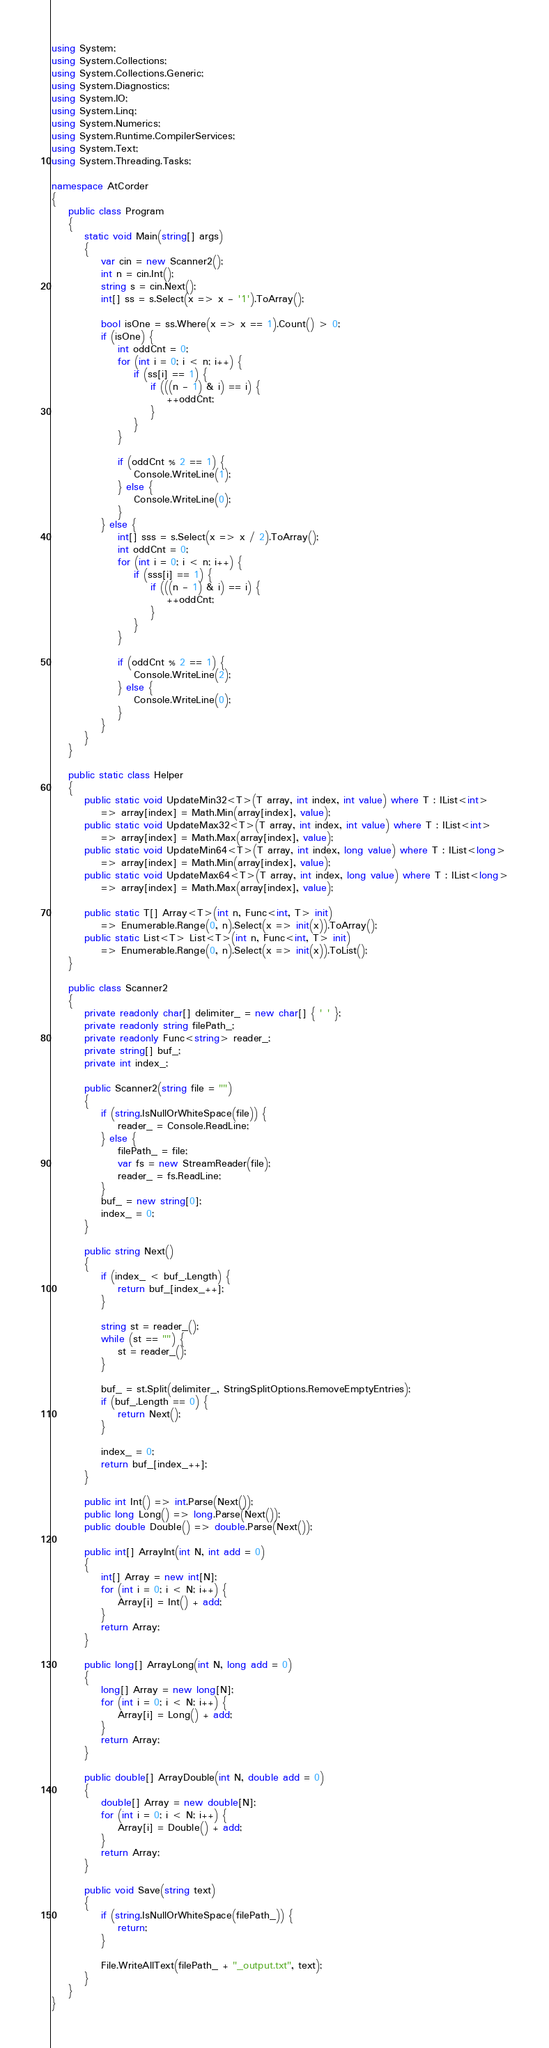Convert code to text. <code><loc_0><loc_0><loc_500><loc_500><_C#_>using System;
using System.Collections;
using System.Collections.Generic;
using System.Diagnostics;
using System.IO;
using System.Linq;
using System.Numerics;
using System.Runtime.CompilerServices;
using System.Text;
using System.Threading.Tasks;

namespace AtCorder
{
	public class Program
	{
		static void Main(string[] args)
		{
			var cin = new Scanner2();
			int n = cin.Int();
			string s = cin.Next();
			int[] ss = s.Select(x => x - '1').ToArray();

			bool isOne = ss.Where(x => x == 1).Count() > 0;
			if (isOne) {
				int oddCnt = 0;
				for (int i = 0; i < n; i++) {
					if (ss[i] == 1) {
						if (((n - 1) & i) == i) {
							++oddCnt;
						}
					}
				}

				if (oddCnt % 2 == 1) {
					Console.WriteLine(1);
				} else {
					Console.WriteLine(0);
				}
			} else {
				int[] sss = s.Select(x => x / 2).ToArray();
				int oddCnt = 0;
				for (int i = 0; i < n; i++) {
					if (sss[i] == 1) {
						if (((n - 1) & i) == i) {
							++oddCnt;
						}
					}
				}

				if (oddCnt % 2 == 1) {
					Console.WriteLine(2);
				} else {
					Console.WriteLine(0);
				}
			}
		}
	}

	public static class Helper
	{
		public static void UpdateMin32<T>(T array, int index, int value) where T : IList<int>
			=> array[index] = Math.Min(array[index], value);
		public static void UpdateMax32<T>(T array, int index, int value) where T : IList<int>
			=> array[index] = Math.Max(array[index], value);
		public static void UpdateMin64<T>(T array, int index, long value) where T : IList<long>
			=> array[index] = Math.Min(array[index], value);
		public static void UpdateMax64<T>(T array, int index, long value) where T : IList<long>
			=> array[index] = Math.Max(array[index], value);

		public static T[] Array<T>(int n, Func<int, T> init)
			=> Enumerable.Range(0, n).Select(x => init(x)).ToArray();
		public static List<T> List<T>(int n, Func<int, T> init)
			=> Enumerable.Range(0, n).Select(x => init(x)).ToList();
	}

	public class Scanner2
	{
		private readonly char[] delimiter_ = new char[] { ' ' };
		private readonly string filePath_;
		private readonly Func<string> reader_;
		private string[] buf_;
		private int index_;

		public Scanner2(string file = "")
		{
			if (string.IsNullOrWhiteSpace(file)) {
				reader_ = Console.ReadLine;
			} else {
				filePath_ = file;
				var fs = new StreamReader(file);
				reader_ = fs.ReadLine;
			}
			buf_ = new string[0];
			index_ = 0;
		}

		public string Next()
		{
			if (index_ < buf_.Length) {
				return buf_[index_++];
			}

			string st = reader_();
			while (st == "") {
				st = reader_();
			}

			buf_ = st.Split(delimiter_, StringSplitOptions.RemoveEmptyEntries);
			if (buf_.Length == 0) {
				return Next();
			}

			index_ = 0;
			return buf_[index_++];
		}

		public int Int() => int.Parse(Next());
		public long Long() => long.Parse(Next());
		public double Double() => double.Parse(Next());

		public int[] ArrayInt(int N, int add = 0)
		{
			int[] Array = new int[N];
			for (int i = 0; i < N; i++) {
				Array[i] = Int() + add;
			}
			return Array;
		}

		public long[] ArrayLong(int N, long add = 0)
		{
			long[] Array = new long[N];
			for (int i = 0; i < N; i++) {
				Array[i] = Long() + add;
			}
			return Array;
		}

		public double[] ArrayDouble(int N, double add = 0)
		{
			double[] Array = new double[N];
			for (int i = 0; i < N; i++) {
				Array[i] = Double() + add;
			}
			return Array;
		}

		public void Save(string text)
		{
			if (string.IsNullOrWhiteSpace(filePath_)) {
				return;
			}

			File.WriteAllText(filePath_ + "_output.txt", text);
		}
	}
}</code> 